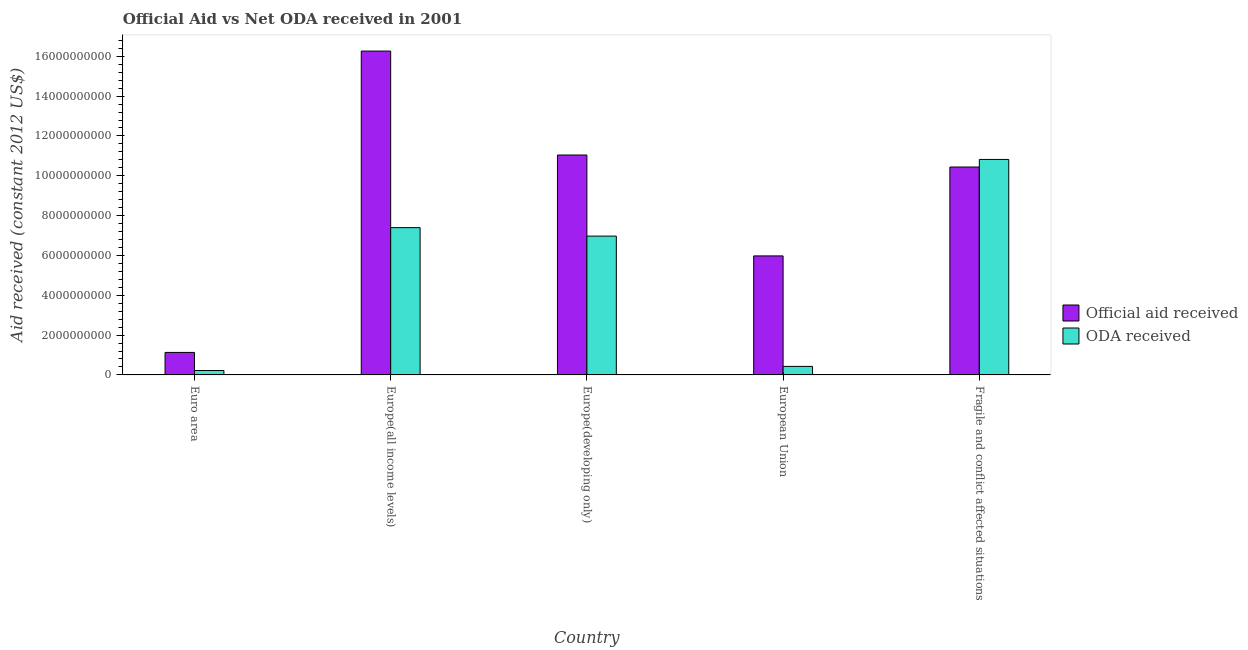How many groups of bars are there?
Keep it short and to the point. 5. What is the label of the 5th group of bars from the left?
Your response must be concise. Fragile and conflict affected situations. In how many cases, is the number of bars for a given country not equal to the number of legend labels?
Provide a succinct answer. 0. What is the official aid received in Europe(all income levels)?
Your response must be concise. 1.63e+1. Across all countries, what is the maximum oda received?
Give a very brief answer. 1.08e+1. Across all countries, what is the minimum official aid received?
Ensure brevity in your answer.  1.13e+09. In which country was the official aid received maximum?
Your response must be concise. Europe(all income levels). What is the total official aid received in the graph?
Give a very brief answer. 4.48e+1. What is the difference between the official aid received in Europe(all income levels) and that in Europe(developing only)?
Offer a very short reply. 5.22e+09. What is the difference between the official aid received in Euro area and the oda received in Fragile and conflict affected situations?
Make the answer very short. -9.69e+09. What is the average oda received per country?
Make the answer very short. 5.17e+09. What is the difference between the official aid received and oda received in Europe(developing only)?
Offer a very short reply. 4.07e+09. In how many countries, is the oda received greater than 2400000000 US$?
Your answer should be compact. 3. What is the ratio of the oda received in Europe(all income levels) to that in Fragile and conflict affected situations?
Offer a very short reply. 0.68. Is the official aid received in European Union less than that in Fragile and conflict affected situations?
Make the answer very short. Yes. What is the difference between the highest and the second highest official aid received?
Offer a terse response. 5.22e+09. What is the difference between the highest and the lowest oda received?
Offer a very short reply. 1.06e+1. In how many countries, is the oda received greater than the average oda received taken over all countries?
Ensure brevity in your answer.  3. Is the sum of the official aid received in Europe(all income levels) and European Union greater than the maximum oda received across all countries?
Provide a short and direct response. Yes. What does the 2nd bar from the left in Euro area represents?
Keep it short and to the point. ODA received. What does the 1st bar from the right in European Union represents?
Ensure brevity in your answer.  ODA received. How many bars are there?
Keep it short and to the point. 10. Are all the bars in the graph horizontal?
Provide a succinct answer. No. What is the difference between two consecutive major ticks on the Y-axis?
Offer a terse response. 2.00e+09. Are the values on the major ticks of Y-axis written in scientific E-notation?
Offer a very short reply. No. Does the graph contain any zero values?
Ensure brevity in your answer.  No. Does the graph contain grids?
Offer a terse response. No. How are the legend labels stacked?
Offer a terse response. Vertical. What is the title of the graph?
Ensure brevity in your answer.  Official Aid vs Net ODA received in 2001 . Does "National Visitors" appear as one of the legend labels in the graph?
Your answer should be very brief. No. What is the label or title of the Y-axis?
Provide a short and direct response. Aid received (constant 2012 US$). What is the Aid received (constant 2012 US$) of Official aid received in Euro area?
Offer a very short reply. 1.13e+09. What is the Aid received (constant 2012 US$) of ODA received in Euro area?
Give a very brief answer. 2.21e+08. What is the Aid received (constant 2012 US$) of Official aid received in Europe(all income levels)?
Your answer should be compact. 1.63e+1. What is the Aid received (constant 2012 US$) of ODA received in Europe(all income levels)?
Ensure brevity in your answer.  7.39e+09. What is the Aid received (constant 2012 US$) in Official aid received in Europe(developing only)?
Ensure brevity in your answer.  1.10e+1. What is the Aid received (constant 2012 US$) in ODA received in Europe(developing only)?
Offer a terse response. 6.97e+09. What is the Aid received (constant 2012 US$) of Official aid received in European Union?
Your response must be concise. 5.98e+09. What is the Aid received (constant 2012 US$) of ODA received in European Union?
Offer a terse response. 4.28e+08. What is the Aid received (constant 2012 US$) in Official aid received in Fragile and conflict affected situations?
Give a very brief answer. 1.04e+1. What is the Aid received (constant 2012 US$) of ODA received in Fragile and conflict affected situations?
Offer a terse response. 1.08e+1. Across all countries, what is the maximum Aid received (constant 2012 US$) in Official aid received?
Provide a short and direct response. 1.63e+1. Across all countries, what is the maximum Aid received (constant 2012 US$) in ODA received?
Provide a short and direct response. 1.08e+1. Across all countries, what is the minimum Aid received (constant 2012 US$) of Official aid received?
Give a very brief answer. 1.13e+09. Across all countries, what is the minimum Aid received (constant 2012 US$) in ODA received?
Keep it short and to the point. 2.21e+08. What is the total Aid received (constant 2012 US$) in Official aid received in the graph?
Provide a succinct answer. 4.48e+1. What is the total Aid received (constant 2012 US$) of ODA received in the graph?
Provide a short and direct response. 2.58e+1. What is the difference between the Aid received (constant 2012 US$) in Official aid received in Euro area and that in Europe(all income levels)?
Your response must be concise. -1.51e+1. What is the difference between the Aid received (constant 2012 US$) of ODA received in Euro area and that in Europe(all income levels)?
Your response must be concise. -7.17e+09. What is the difference between the Aid received (constant 2012 US$) of Official aid received in Euro area and that in Europe(developing only)?
Ensure brevity in your answer.  -9.91e+09. What is the difference between the Aid received (constant 2012 US$) in ODA received in Euro area and that in Europe(developing only)?
Offer a terse response. -6.75e+09. What is the difference between the Aid received (constant 2012 US$) of Official aid received in Euro area and that in European Union?
Keep it short and to the point. -4.85e+09. What is the difference between the Aid received (constant 2012 US$) of ODA received in Euro area and that in European Union?
Keep it short and to the point. -2.07e+08. What is the difference between the Aid received (constant 2012 US$) in Official aid received in Euro area and that in Fragile and conflict affected situations?
Keep it short and to the point. -9.31e+09. What is the difference between the Aid received (constant 2012 US$) of ODA received in Euro area and that in Fragile and conflict affected situations?
Your response must be concise. -1.06e+1. What is the difference between the Aid received (constant 2012 US$) in Official aid received in Europe(all income levels) and that in Europe(developing only)?
Offer a terse response. 5.22e+09. What is the difference between the Aid received (constant 2012 US$) in ODA received in Europe(all income levels) and that in Europe(developing only)?
Give a very brief answer. 4.25e+08. What is the difference between the Aid received (constant 2012 US$) of Official aid received in Europe(all income levels) and that in European Union?
Ensure brevity in your answer.  1.03e+1. What is the difference between the Aid received (constant 2012 US$) in ODA received in Europe(all income levels) and that in European Union?
Provide a succinct answer. 6.97e+09. What is the difference between the Aid received (constant 2012 US$) of Official aid received in Europe(all income levels) and that in Fragile and conflict affected situations?
Ensure brevity in your answer.  5.82e+09. What is the difference between the Aid received (constant 2012 US$) of ODA received in Europe(all income levels) and that in Fragile and conflict affected situations?
Make the answer very short. -3.42e+09. What is the difference between the Aid received (constant 2012 US$) in Official aid received in Europe(developing only) and that in European Union?
Ensure brevity in your answer.  5.07e+09. What is the difference between the Aid received (constant 2012 US$) of ODA received in Europe(developing only) and that in European Union?
Make the answer very short. 6.54e+09. What is the difference between the Aid received (constant 2012 US$) of Official aid received in Europe(developing only) and that in Fragile and conflict affected situations?
Provide a short and direct response. 6.04e+08. What is the difference between the Aid received (constant 2012 US$) in ODA received in Europe(developing only) and that in Fragile and conflict affected situations?
Provide a short and direct response. -3.85e+09. What is the difference between the Aid received (constant 2012 US$) of Official aid received in European Union and that in Fragile and conflict affected situations?
Ensure brevity in your answer.  -4.46e+09. What is the difference between the Aid received (constant 2012 US$) in ODA received in European Union and that in Fragile and conflict affected situations?
Ensure brevity in your answer.  -1.04e+1. What is the difference between the Aid received (constant 2012 US$) in Official aid received in Euro area and the Aid received (constant 2012 US$) in ODA received in Europe(all income levels)?
Keep it short and to the point. -6.26e+09. What is the difference between the Aid received (constant 2012 US$) in Official aid received in Euro area and the Aid received (constant 2012 US$) in ODA received in Europe(developing only)?
Your answer should be compact. -5.84e+09. What is the difference between the Aid received (constant 2012 US$) in Official aid received in Euro area and the Aid received (constant 2012 US$) in ODA received in European Union?
Your answer should be very brief. 7.02e+08. What is the difference between the Aid received (constant 2012 US$) of Official aid received in Euro area and the Aid received (constant 2012 US$) of ODA received in Fragile and conflict affected situations?
Your answer should be very brief. -9.69e+09. What is the difference between the Aid received (constant 2012 US$) in Official aid received in Europe(all income levels) and the Aid received (constant 2012 US$) in ODA received in Europe(developing only)?
Ensure brevity in your answer.  9.29e+09. What is the difference between the Aid received (constant 2012 US$) of Official aid received in Europe(all income levels) and the Aid received (constant 2012 US$) of ODA received in European Union?
Keep it short and to the point. 1.58e+1. What is the difference between the Aid received (constant 2012 US$) of Official aid received in Europe(all income levels) and the Aid received (constant 2012 US$) of ODA received in Fragile and conflict affected situations?
Offer a very short reply. 5.44e+09. What is the difference between the Aid received (constant 2012 US$) in Official aid received in Europe(developing only) and the Aid received (constant 2012 US$) in ODA received in European Union?
Your answer should be compact. 1.06e+1. What is the difference between the Aid received (constant 2012 US$) in Official aid received in Europe(developing only) and the Aid received (constant 2012 US$) in ODA received in Fragile and conflict affected situations?
Give a very brief answer. 2.23e+08. What is the difference between the Aid received (constant 2012 US$) of Official aid received in European Union and the Aid received (constant 2012 US$) of ODA received in Fragile and conflict affected situations?
Keep it short and to the point. -4.84e+09. What is the average Aid received (constant 2012 US$) in Official aid received per country?
Provide a succinct answer. 8.97e+09. What is the average Aid received (constant 2012 US$) of ODA received per country?
Your answer should be compact. 5.17e+09. What is the difference between the Aid received (constant 2012 US$) of Official aid received and Aid received (constant 2012 US$) of ODA received in Euro area?
Provide a short and direct response. 9.09e+08. What is the difference between the Aid received (constant 2012 US$) of Official aid received and Aid received (constant 2012 US$) of ODA received in Europe(all income levels)?
Make the answer very short. 8.87e+09. What is the difference between the Aid received (constant 2012 US$) in Official aid received and Aid received (constant 2012 US$) in ODA received in Europe(developing only)?
Provide a short and direct response. 4.07e+09. What is the difference between the Aid received (constant 2012 US$) of Official aid received and Aid received (constant 2012 US$) of ODA received in European Union?
Your response must be concise. 5.55e+09. What is the difference between the Aid received (constant 2012 US$) in Official aid received and Aid received (constant 2012 US$) in ODA received in Fragile and conflict affected situations?
Your answer should be very brief. -3.81e+08. What is the ratio of the Aid received (constant 2012 US$) of Official aid received in Euro area to that in Europe(all income levels)?
Offer a terse response. 0.07. What is the ratio of the Aid received (constant 2012 US$) in ODA received in Euro area to that in Europe(all income levels)?
Give a very brief answer. 0.03. What is the ratio of the Aid received (constant 2012 US$) in Official aid received in Euro area to that in Europe(developing only)?
Keep it short and to the point. 0.1. What is the ratio of the Aid received (constant 2012 US$) in ODA received in Euro area to that in Europe(developing only)?
Offer a terse response. 0.03. What is the ratio of the Aid received (constant 2012 US$) in Official aid received in Euro area to that in European Union?
Offer a terse response. 0.19. What is the ratio of the Aid received (constant 2012 US$) of ODA received in Euro area to that in European Union?
Provide a short and direct response. 0.52. What is the ratio of the Aid received (constant 2012 US$) of Official aid received in Euro area to that in Fragile and conflict affected situations?
Ensure brevity in your answer.  0.11. What is the ratio of the Aid received (constant 2012 US$) of ODA received in Euro area to that in Fragile and conflict affected situations?
Your answer should be compact. 0.02. What is the ratio of the Aid received (constant 2012 US$) in Official aid received in Europe(all income levels) to that in Europe(developing only)?
Ensure brevity in your answer.  1.47. What is the ratio of the Aid received (constant 2012 US$) in ODA received in Europe(all income levels) to that in Europe(developing only)?
Offer a terse response. 1.06. What is the ratio of the Aid received (constant 2012 US$) in Official aid received in Europe(all income levels) to that in European Union?
Your answer should be very brief. 2.72. What is the ratio of the Aid received (constant 2012 US$) in ODA received in Europe(all income levels) to that in European Union?
Give a very brief answer. 17.29. What is the ratio of the Aid received (constant 2012 US$) in Official aid received in Europe(all income levels) to that in Fragile and conflict affected situations?
Make the answer very short. 1.56. What is the ratio of the Aid received (constant 2012 US$) in ODA received in Europe(all income levels) to that in Fragile and conflict affected situations?
Provide a short and direct response. 0.68. What is the ratio of the Aid received (constant 2012 US$) in Official aid received in Europe(developing only) to that in European Union?
Offer a terse response. 1.85. What is the ratio of the Aid received (constant 2012 US$) of ODA received in Europe(developing only) to that in European Union?
Give a very brief answer. 16.3. What is the ratio of the Aid received (constant 2012 US$) in Official aid received in Europe(developing only) to that in Fragile and conflict affected situations?
Your response must be concise. 1.06. What is the ratio of the Aid received (constant 2012 US$) of ODA received in Europe(developing only) to that in Fragile and conflict affected situations?
Provide a succinct answer. 0.64. What is the ratio of the Aid received (constant 2012 US$) of Official aid received in European Union to that in Fragile and conflict affected situations?
Keep it short and to the point. 0.57. What is the ratio of the Aid received (constant 2012 US$) of ODA received in European Union to that in Fragile and conflict affected situations?
Make the answer very short. 0.04. What is the difference between the highest and the second highest Aid received (constant 2012 US$) of Official aid received?
Your answer should be very brief. 5.22e+09. What is the difference between the highest and the second highest Aid received (constant 2012 US$) in ODA received?
Keep it short and to the point. 3.42e+09. What is the difference between the highest and the lowest Aid received (constant 2012 US$) in Official aid received?
Offer a terse response. 1.51e+1. What is the difference between the highest and the lowest Aid received (constant 2012 US$) in ODA received?
Your response must be concise. 1.06e+1. 